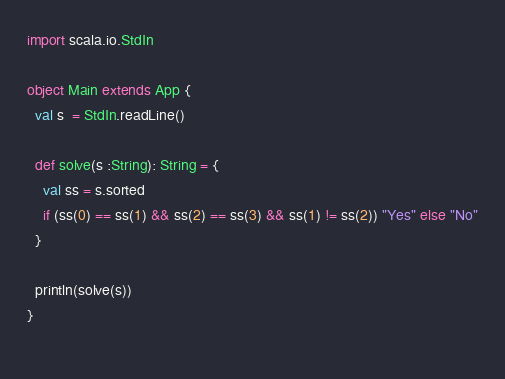Convert code to text. <code><loc_0><loc_0><loc_500><loc_500><_Scala_>import scala.io.StdIn

object Main extends App {
  val s  = StdIn.readLine()

  def solve(s :String): String = {
    val ss = s.sorted
    if (ss(0) == ss(1) && ss(2) == ss(3) && ss(1) != ss(2)) "Yes" else "No"
  }

  println(solve(s))
}
  

</code> 